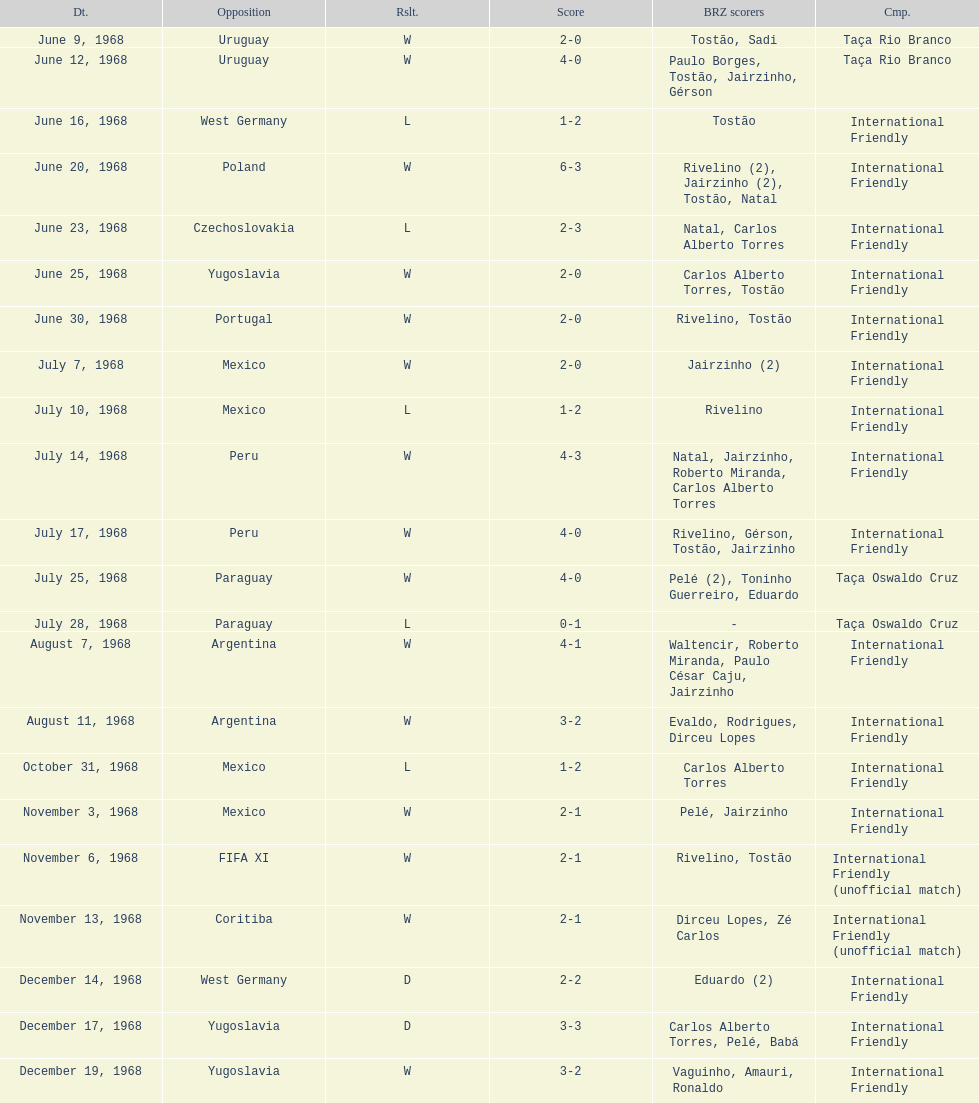What's the total number of ties? 2. 